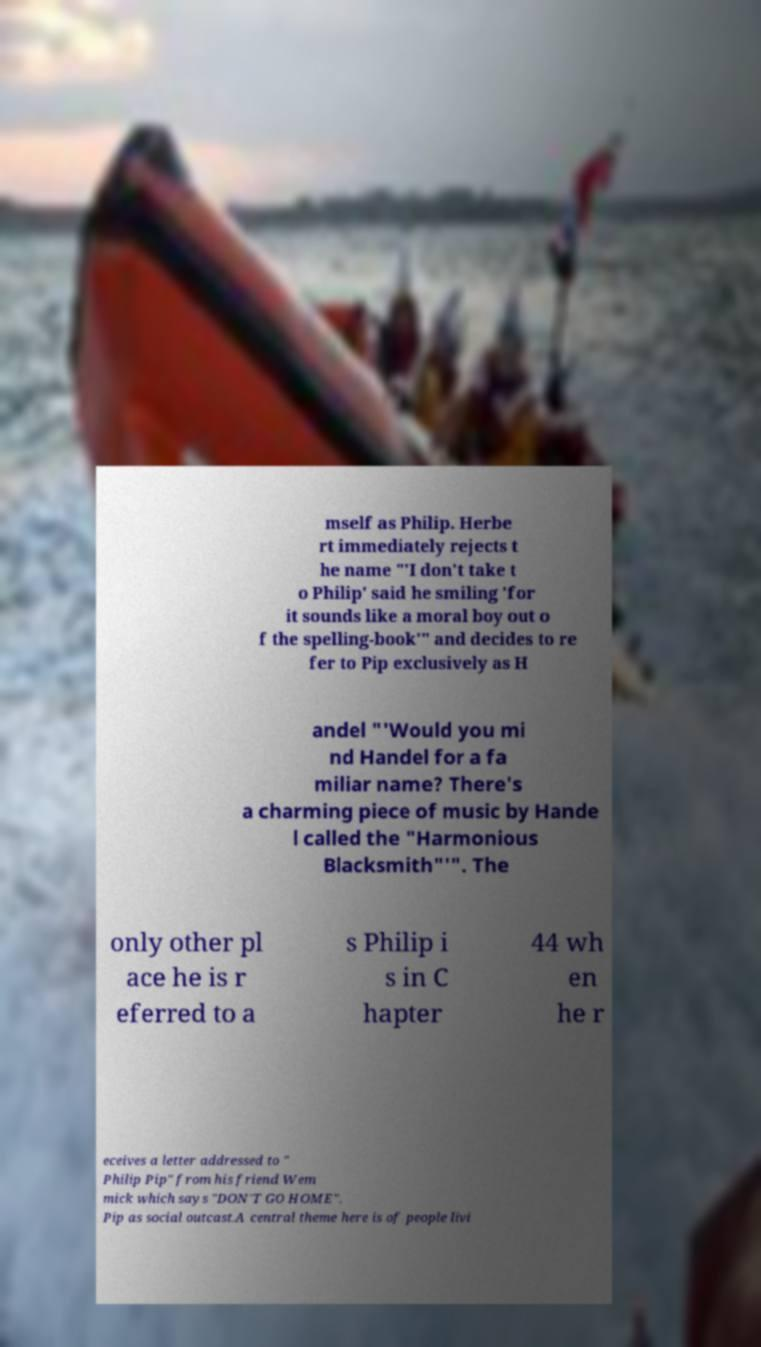I need the written content from this picture converted into text. Can you do that? mself as Philip. Herbe rt immediately rejects t he name "'I don't take t o Philip' said he smiling 'for it sounds like a moral boy out o f the spelling-book'" and decides to re fer to Pip exclusively as H andel "'Would you mi nd Handel for a fa miliar name? There's a charming piece of music by Hande l called the "Harmonious Blacksmith"'". The only other pl ace he is r eferred to a s Philip i s in C hapter 44 wh en he r eceives a letter addressed to " Philip Pip" from his friend Wem mick which says "DON'T GO HOME". Pip as social outcast.A central theme here is of people livi 